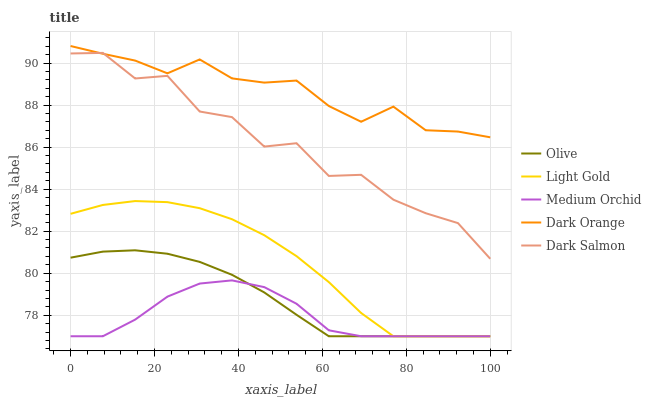Does Medium Orchid have the minimum area under the curve?
Answer yes or no. Yes. Does Dark Orange have the maximum area under the curve?
Answer yes or no. Yes. Does Dark Orange have the minimum area under the curve?
Answer yes or no. No. Does Medium Orchid have the maximum area under the curve?
Answer yes or no. No. Is Olive the smoothest?
Answer yes or no. Yes. Is Dark Salmon the roughest?
Answer yes or no. Yes. Is Dark Orange the smoothest?
Answer yes or no. No. Is Dark Orange the roughest?
Answer yes or no. No. Does Olive have the lowest value?
Answer yes or no. Yes. Does Dark Orange have the lowest value?
Answer yes or no. No. Does Dark Orange have the highest value?
Answer yes or no. Yes. Does Medium Orchid have the highest value?
Answer yes or no. No. Is Olive less than Dark Salmon?
Answer yes or no. Yes. Is Dark Orange greater than Light Gold?
Answer yes or no. Yes. Does Dark Salmon intersect Dark Orange?
Answer yes or no. Yes. Is Dark Salmon less than Dark Orange?
Answer yes or no. No. Is Dark Salmon greater than Dark Orange?
Answer yes or no. No. Does Olive intersect Dark Salmon?
Answer yes or no. No. 